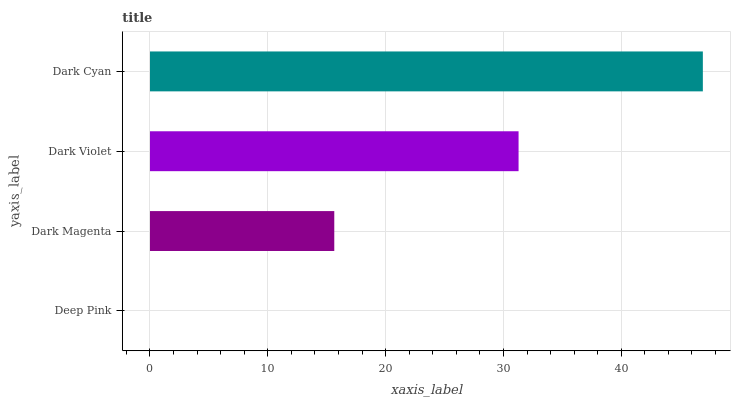Is Deep Pink the minimum?
Answer yes or no. Yes. Is Dark Cyan the maximum?
Answer yes or no. Yes. Is Dark Magenta the minimum?
Answer yes or no. No. Is Dark Magenta the maximum?
Answer yes or no. No. Is Dark Magenta greater than Deep Pink?
Answer yes or no. Yes. Is Deep Pink less than Dark Magenta?
Answer yes or no. Yes. Is Deep Pink greater than Dark Magenta?
Answer yes or no. No. Is Dark Magenta less than Deep Pink?
Answer yes or no. No. Is Dark Violet the high median?
Answer yes or no. Yes. Is Dark Magenta the low median?
Answer yes or no. Yes. Is Deep Pink the high median?
Answer yes or no. No. Is Deep Pink the low median?
Answer yes or no. No. 